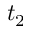<formula> <loc_0><loc_0><loc_500><loc_500>t _ { 2 }</formula> 